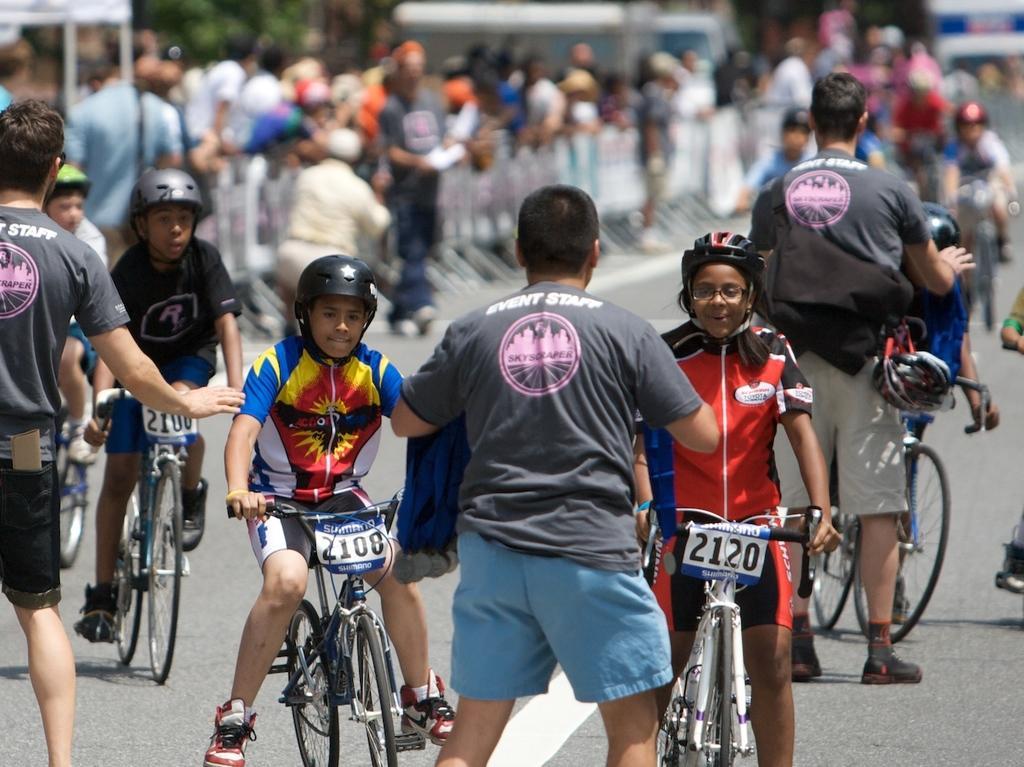Could you give a brief overview of what you see in this image? Here we can see some persons on the bicycles. This is road. There are some persons standing on the road. 